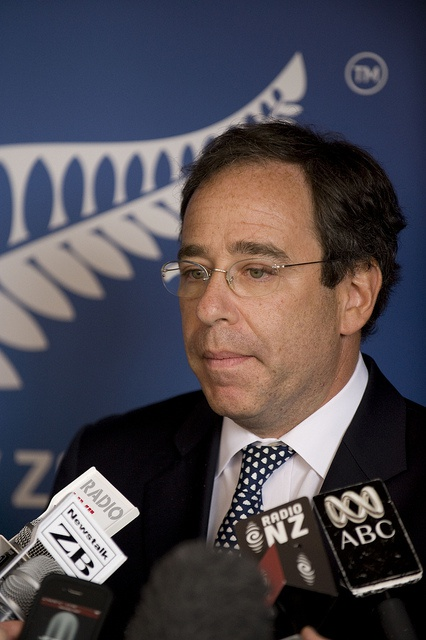Describe the objects in this image and their specific colors. I can see people in navy, black, gray, tan, and lightgray tones and tie in navy, black, gray, darkgray, and lightgray tones in this image. 